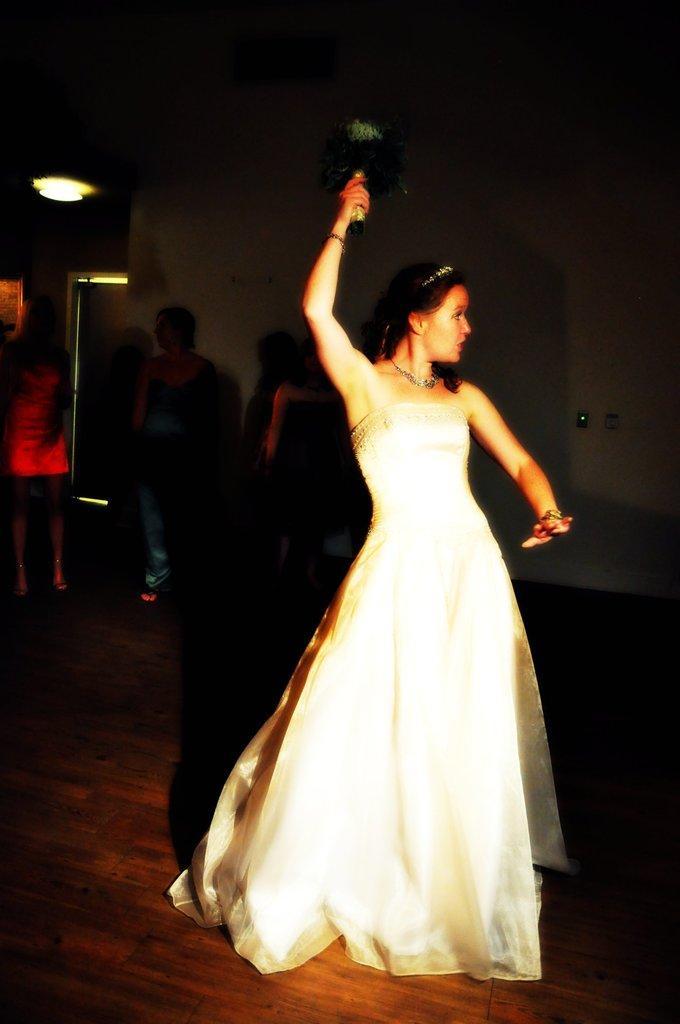Can you describe this image briefly? This picture describes about group of people, in the middle of the image we can see a woman, she is holding an object in her hand, and she wore a white color dress, in the background we can see lights. 